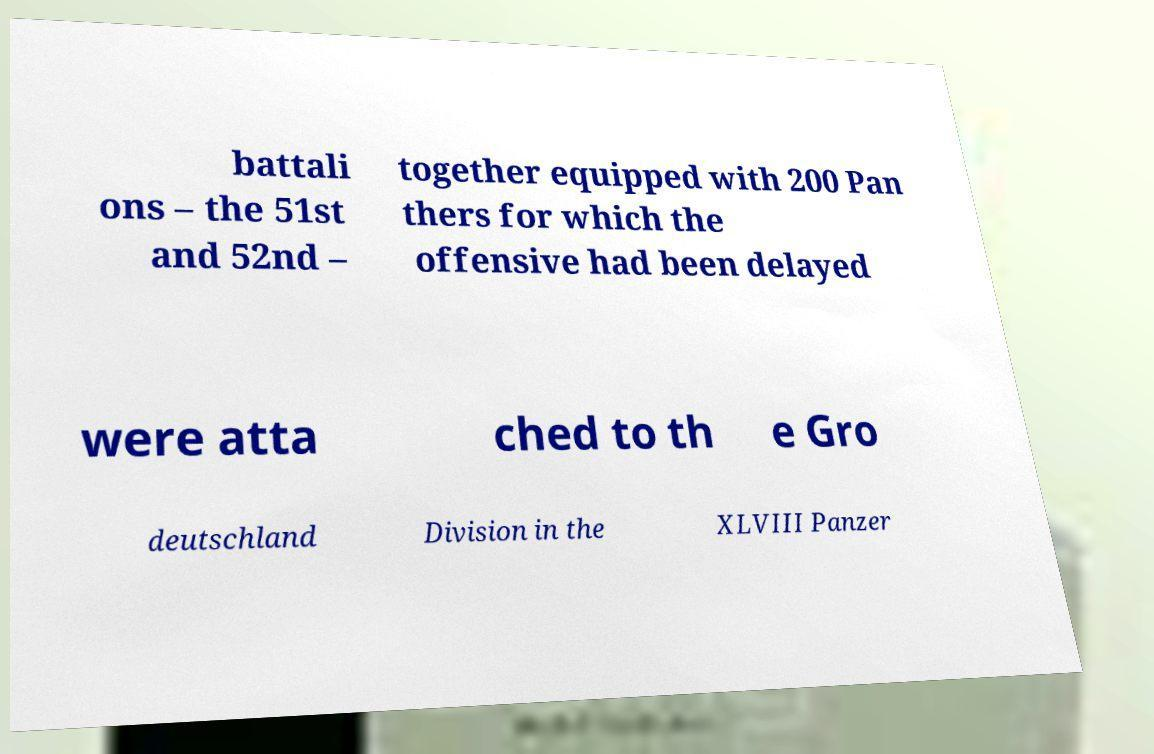Could you assist in decoding the text presented in this image and type it out clearly? battali ons – the 51st and 52nd – together equipped with 200 Pan thers for which the offensive had been delayed were atta ched to th e Gro deutschland Division in the XLVIII Panzer 